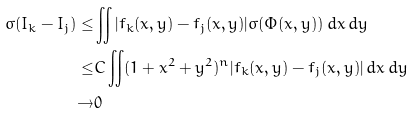Convert formula to latex. <formula><loc_0><loc_0><loc_500><loc_500>\sigma ( I _ { k } - I _ { j } ) \leq & \iint | f _ { k } ( x , y ) - f _ { j } ( x , y ) | \sigma ( \Phi ( x , y ) ) \, d x \, d y \\ \leq & C \iint ( 1 + x ^ { 2 } + y ^ { 2 } ) ^ { n } | f _ { k } ( x , y ) - f _ { j } ( x , y ) | \, d x \, d y \\ \to & 0</formula> 